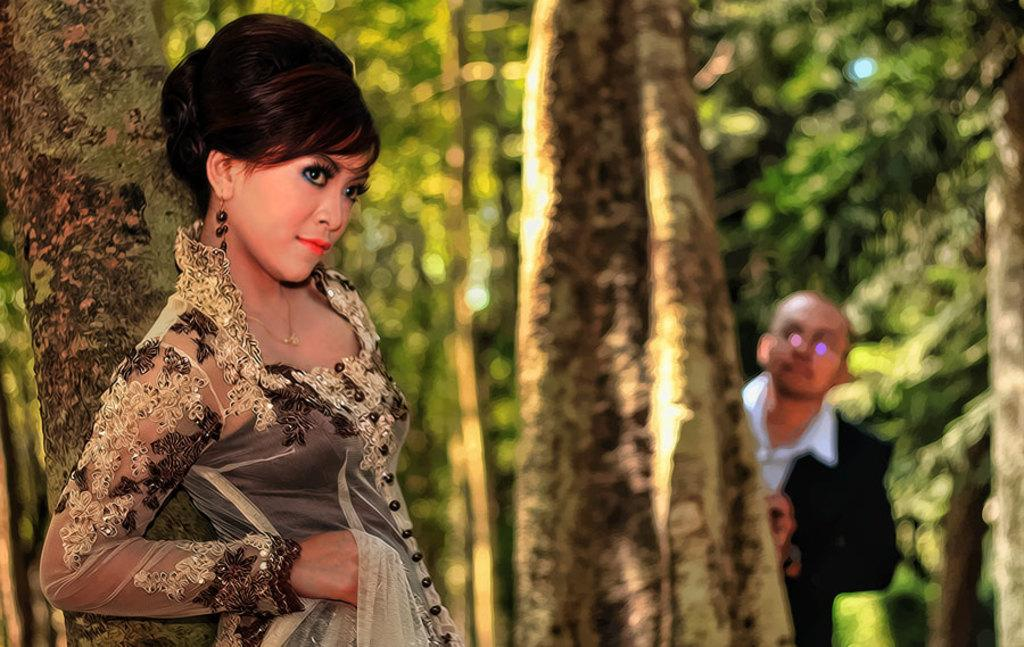Who is standing on the left side of the image? There is a woman standing on the left side of the image. Who is standing on the right side of the image? There is a man standing on the right side of the image. What can be seen in the background of the image? There are trees visible in the background of the image. What type of business is the woman conducting in the bedroom? There is no bedroom or stranger present in the image, and the woman is not conducting any business. 